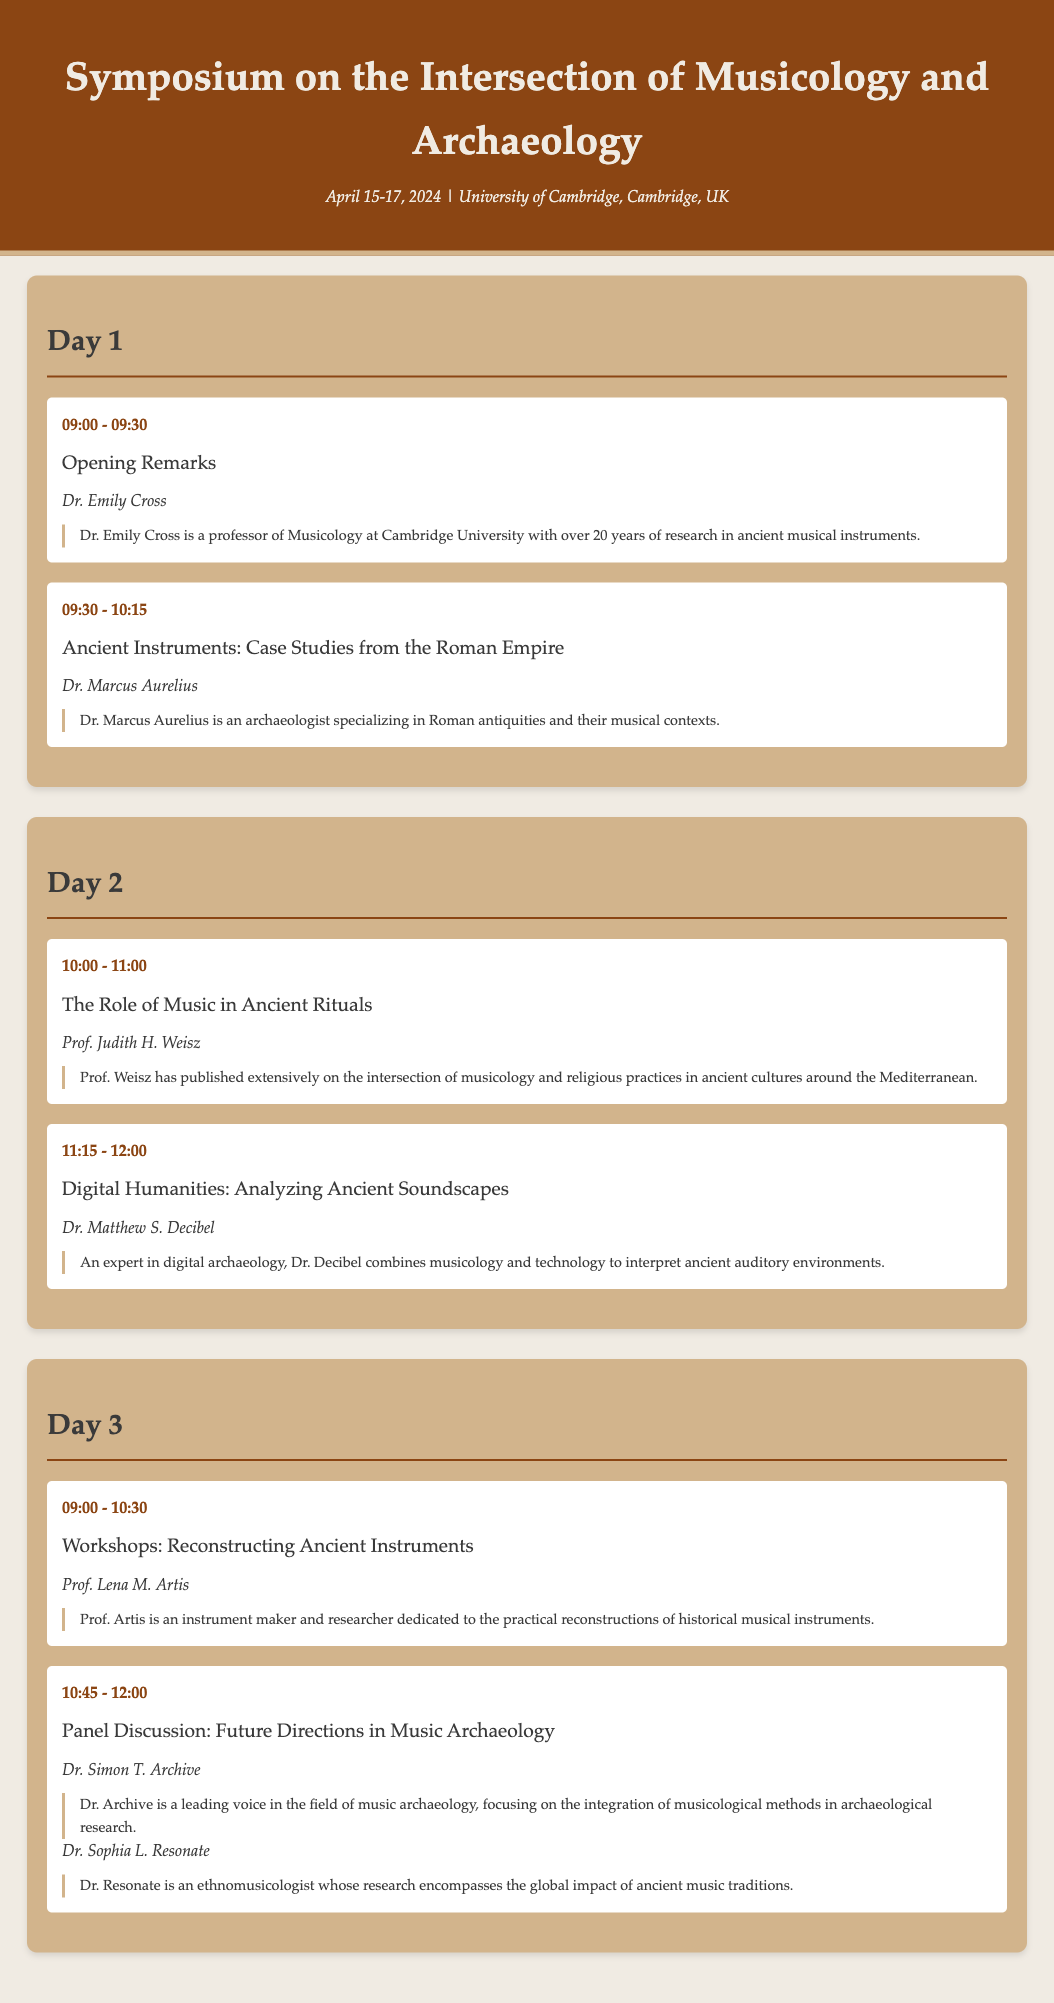What is the date of the symposium? The symposium is scheduled for April 15-17, 2024.
Answer: April 15-17, 2024 Who is the speaker for the opening remarks? The speaker for the opening remarks is Dr. Emily Cross.
Answer: Dr. Emily Cross What topic does Dr. Marcus Aurelius discuss? Dr. Marcus Aurelius discusses ancient instruments from the Roman Empire.
Answer: Ancient Instruments: Case Studies from the Roman Empire What time does the workshop on reconstructing ancient instruments start? The workshop starts at 09:00 on Day 3.
Answer: 09:00 How many speakers are present during the panel discussion? There are two speakers during the panel discussion.
Answer: Two Who specializes in digital archaeology? Dr. Matthew S. Decibel specializes in digital archaeology.
Answer: Dr. Matthew S. Decibel Which professor has published extensively on musicology and ancient religious practices? Prof. Judith H. Weisz has published extensively in this area.
Answer: Prof. Judith H. Weisz What is the focus of Dr. Simon T. Archive's research? Dr. Simon T. Archive focuses on music archaeology and its integration with musicological methods.
Answer: Music archaeology 